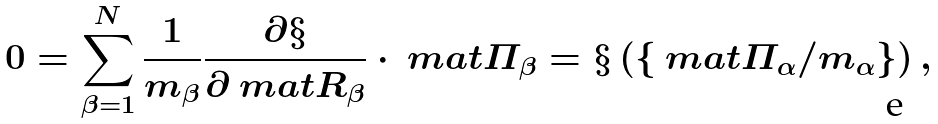<formula> <loc_0><loc_0><loc_500><loc_500>0 = \sum _ { \beta = 1 } ^ { N } \frac { 1 } { m _ { \beta } } \frac { \partial \S } { \partial \ m a t { R } _ { \beta } } \cdot \ m a t { \varPi } _ { \beta } = \S \left ( \left \{ \ m a t { \varPi } _ { \alpha } / m _ { \alpha } \right \} \right ) ,</formula> 